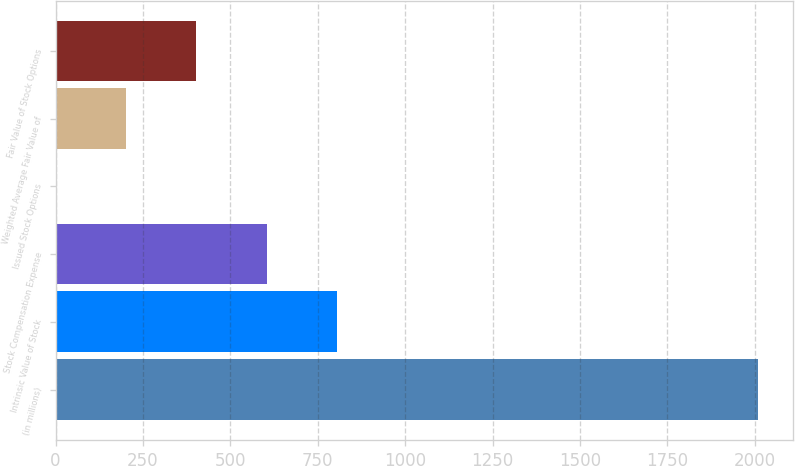Convert chart. <chart><loc_0><loc_0><loc_500><loc_500><bar_chart><fcel>(in millions)<fcel>Intrinsic Value of Stock<fcel>Stock Compensation Expense<fcel>Issued Stock Options<fcel>Weighted Average Fair Value of<fcel>Fair Value of Stock Options<nl><fcel>2009<fcel>804.44<fcel>603.68<fcel>1.4<fcel>202.16<fcel>402.92<nl></chart> 